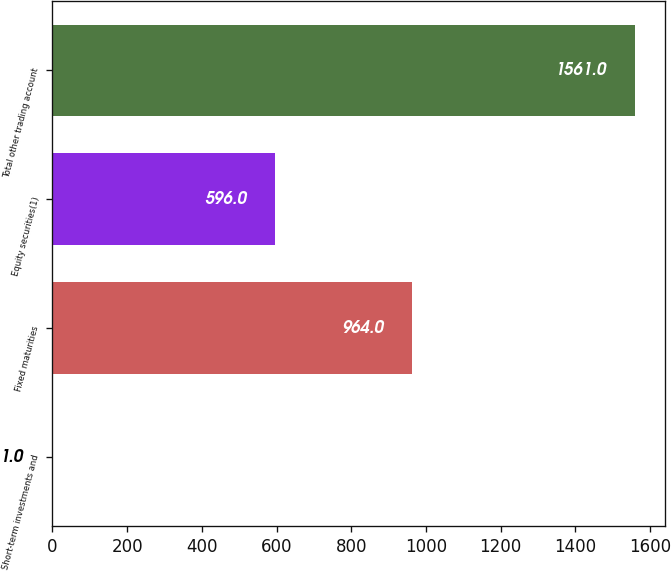<chart> <loc_0><loc_0><loc_500><loc_500><bar_chart><fcel>Short-term investments and<fcel>Fixed maturities<fcel>Equity securities(1)<fcel>Total other trading account<nl><fcel>1<fcel>964<fcel>596<fcel>1561<nl></chart> 